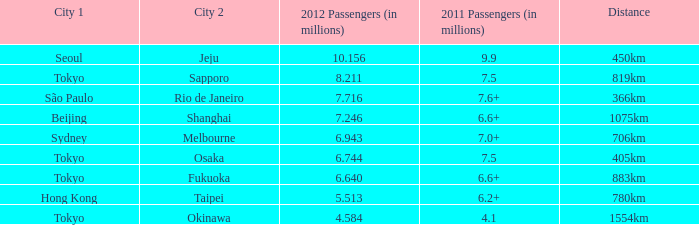What the is the first city listed on the route that had 6.6+ passengers in 2011 and a distance of 1075km? Beijing. 